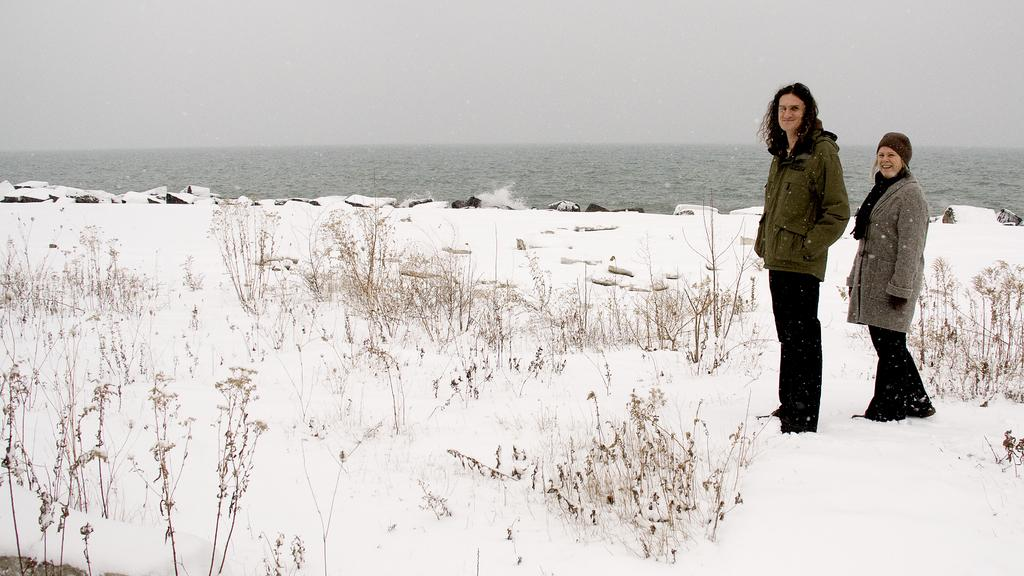How many people are in the image? There are two people standing in the image. What is the ground made of in the image? There is snow at the bottom of the image. What type of vegetation can be seen in the image? There are plants visible in the image. What can be seen in the distance in the image? There is water in the background of the image. What is visible above the water in the image? The sky is visible in the background of the image. What type of gold jewelry is the person on the left wearing in the image? There is no gold jewelry visible on the person on the left in the image. What advice is the person on the right giving to the person on the left in the image? There is no conversation or advice-giving depicted in the image. 